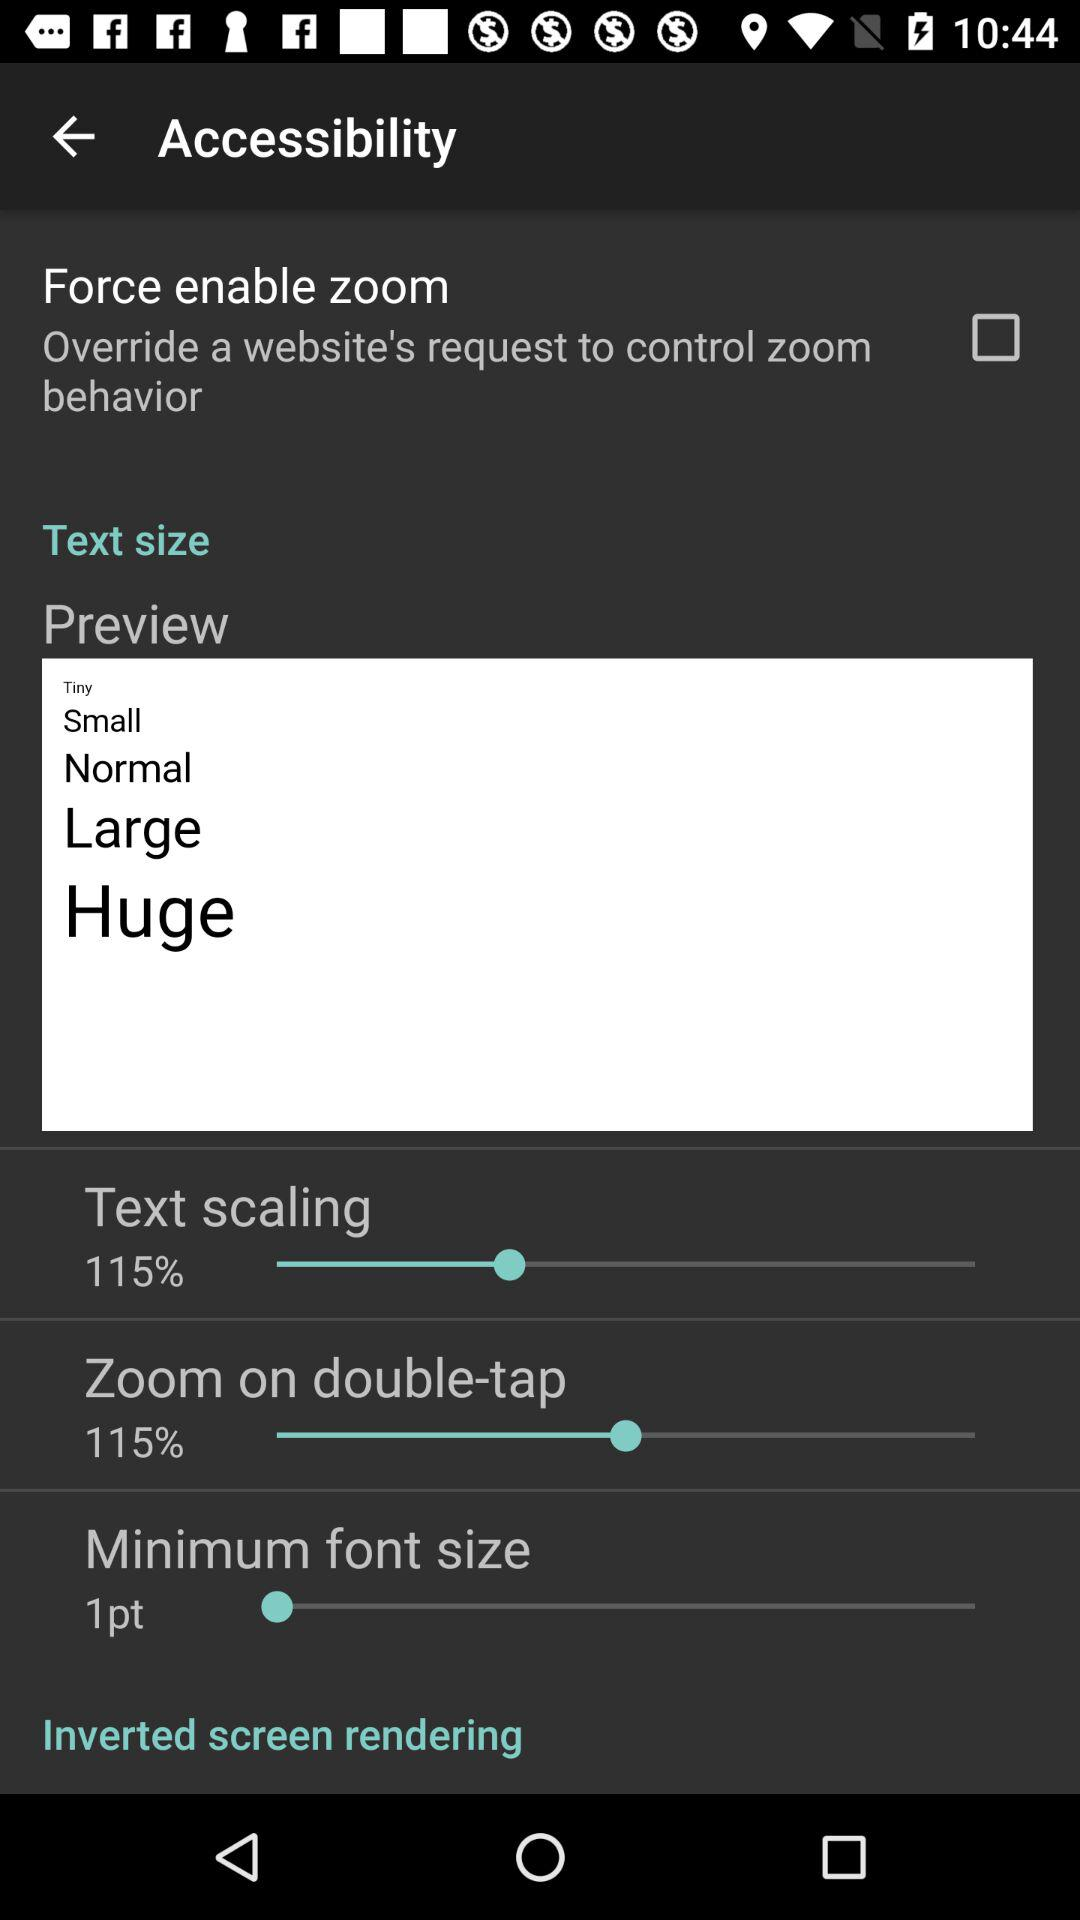Is "Text size" checked or unchecked?
When the provided information is insufficient, respond with <no answer>. <no answer> 